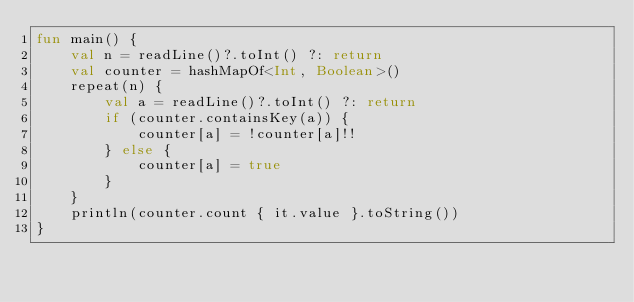Convert code to text. <code><loc_0><loc_0><loc_500><loc_500><_Kotlin_>fun main() {
    val n = readLine()?.toInt() ?: return
    val counter = hashMapOf<Int, Boolean>()
    repeat(n) {
        val a = readLine()?.toInt() ?: return
        if (counter.containsKey(a)) {
            counter[a] = !counter[a]!!
        } else {
            counter[a] = true
        }
    }
    println(counter.count { it.value }.toString())
}</code> 